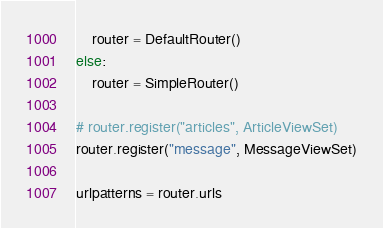Convert code to text. <code><loc_0><loc_0><loc_500><loc_500><_Python_>    router = DefaultRouter()
else:
    router = SimpleRouter()

# router.register("articles", ArticleViewSet)
router.register("message", MessageViewSet)

urlpatterns = router.urls

</code> 